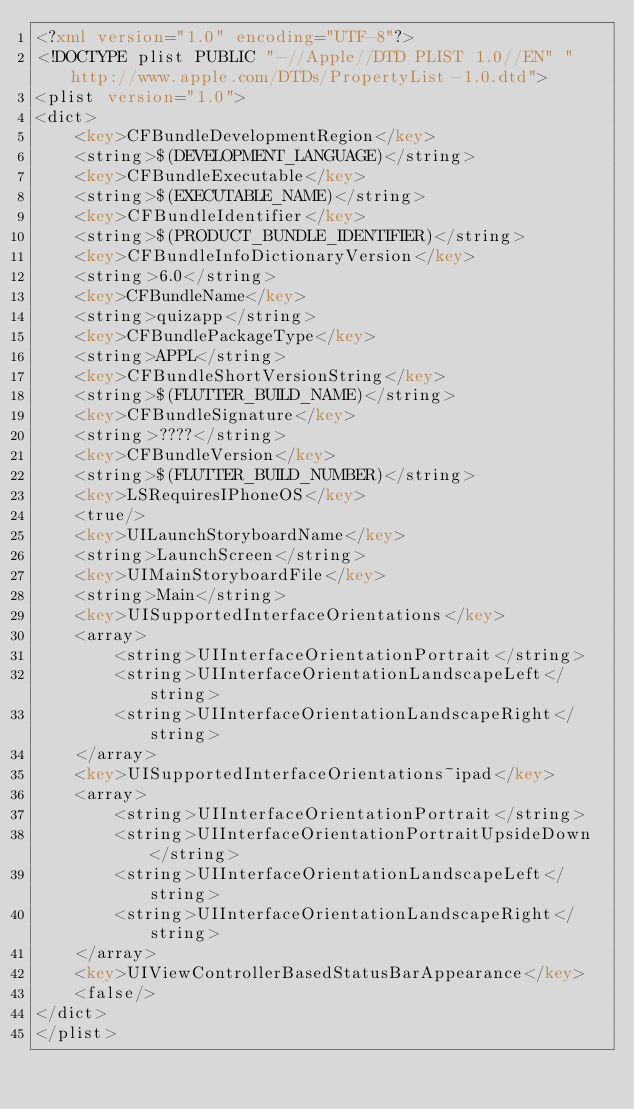<code> <loc_0><loc_0><loc_500><loc_500><_XML_><?xml version="1.0" encoding="UTF-8"?>
<!DOCTYPE plist PUBLIC "-//Apple//DTD PLIST 1.0//EN" "http://www.apple.com/DTDs/PropertyList-1.0.dtd">
<plist version="1.0">
<dict>
	<key>CFBundleDevelopmentRegion</key>
	<string>$(DEVELOPMENT_LANGUAGE)</string>
	<key>CFBundleExecutable</key>
	<string>$(EXECUTABLE_NAME)</string>
	<key>CFBundleIdentifier</key>
	<string>$(PRODUCT_BUNDLE_IDENTIFIER)</string>
	<key>CFBundleInfoDictionaryVersion</key>
	<string>6.0</string>
	<key>CFBundleName</key>
	<string>quizapp</string>
	<key>CFBundlePackageType</key>
	<string>APPL</string>
	<key>CFBundleShortVersionString</key>
	<string>$(FLUTTER_BUILD_NAME)</string>
	<key>CFBundleSignature</key>
	<string>????</string>
	<key>CFBundleVersion</key>
	<string>$(FLUTTER_BUILD_NUMBER)</string>
	<key>LSRequiresIPhoneOS</key>
	<true/>
	<key>UILaunchStoryboardName</key>
	<string>LaunchScreen</string>
	<key>UIMainStoryboardFile</key>
	<string>Main</string>
	<key>UISupportedInterfaceOrientations</key>
	<array>
		<string>UIInterfaceOrientationPortrait</string>
		<string>UIInterfaceOrientationLandscapeLeft</string>
		<string>UIInterfaceOrientationLandscapeRight</string>
	</array>
	<key>UISupportedInterfaceOrientations~ipad</key>
	<array>
		<string>UIInterfaceOrientationPortrait</string>
		<string>UIInterfaceOrientationPortraitUpsideDown</string>
		<string>UIInterfaceOrientationLandscapeLeft</string>
		<string>UIInterfaceOrientationLandscapeRight</string>
	</array>
	<key>UIViewControllerBasedStatusBarAppearance</key>
	<false/>
</dict>
</plist>
</code> 